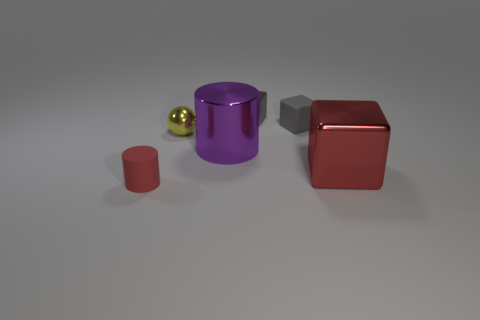What size is the cylinder that is behind the large object that is on the right side of the tiny rubber cube behind the large shiny cube?
Provide a succinct answer. Large. How many red things are blocks or spheres?
Offer a terse response. 1. Is the shape of the red object that is behind the tiny cylinder the same as  the yellow shiny thing?
Offer a terse response. No. Is the number of cylinders that are behind the tiny red rubber thing greater than the number of small rubber cubes?
Your answer should be compact. No. How many purple shiny objects have the same size as the yellow metallic sphere?
Keep it short and to the point. 0. What is the size of the thing that is the same color as the tiny matte cylinder?
Provide a succinct answer. Large. What number of objects are small red rubber blocks or tiny red things that are to the left of the large purple cylinder?
Ensure brevity in your answer.  1. What is the color of the tiny thing that is behind the tiny red cylinder and in front of the tiny gray rubber object?
Keep it short and to the point. Yellow. Is the red cylinder the same size as the red metallic object?
Keep it short and to the point. No. What color is the rubber object that is in front of the large red shiny thing?
Offer a terse response. Red. 